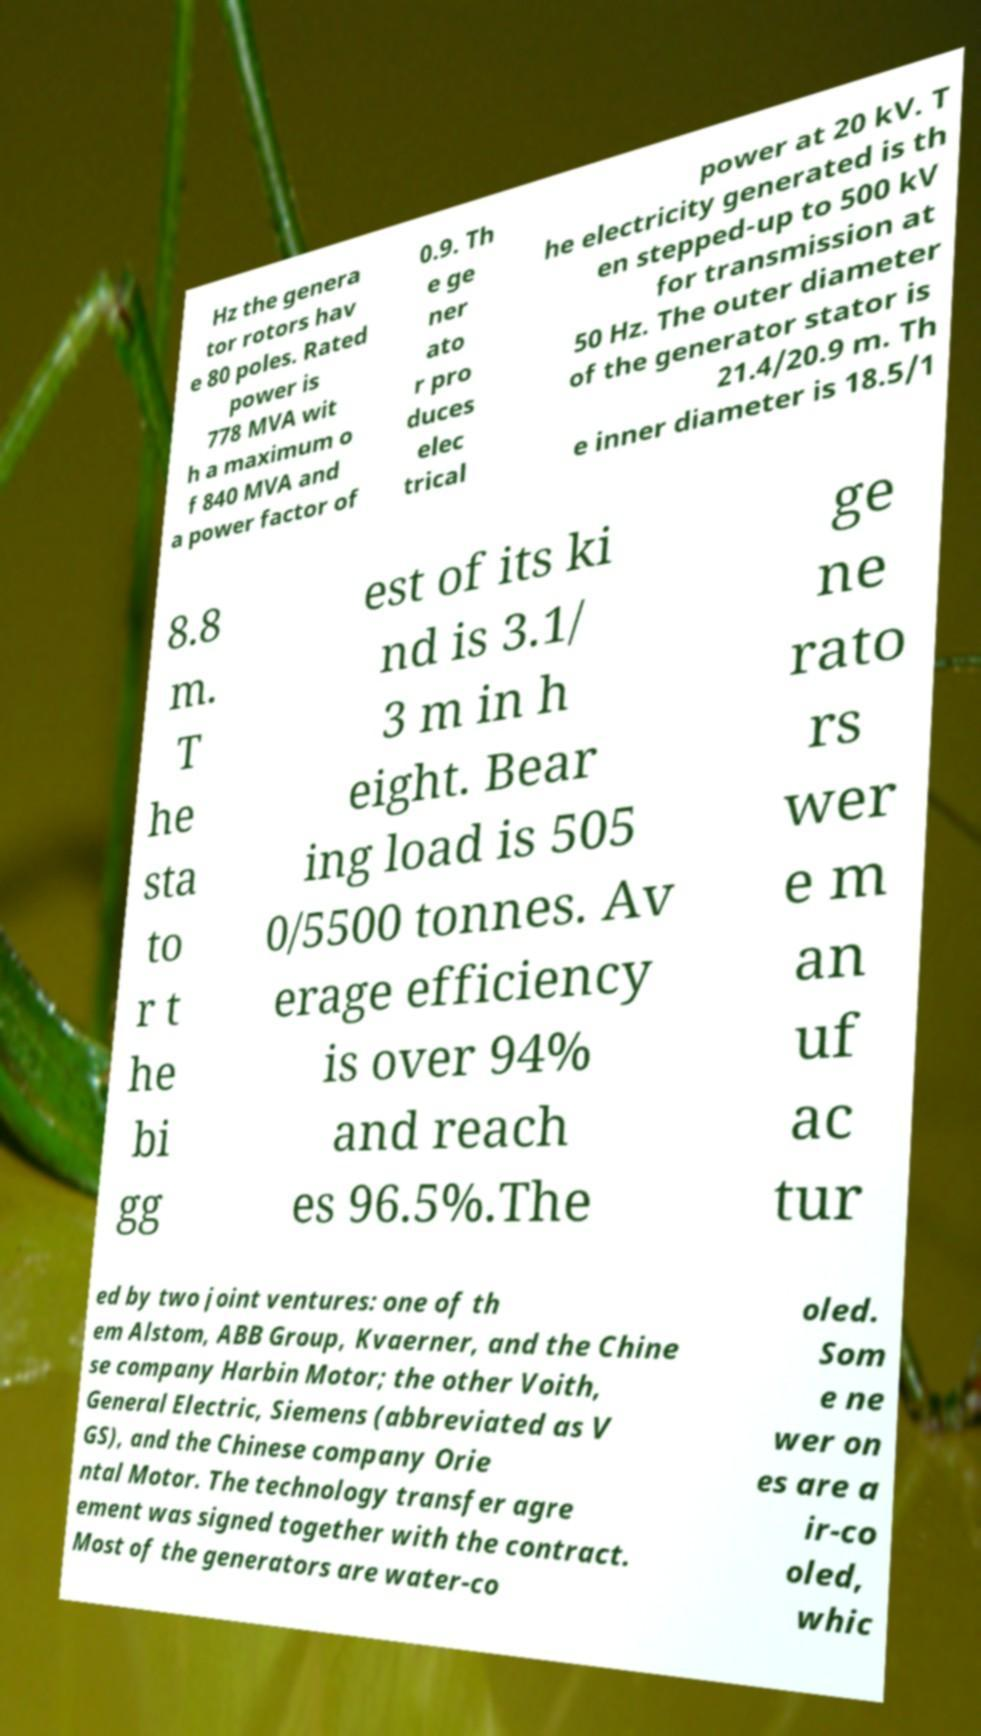Please identify and transcribe the text found in this image. Hz the genera tor rotors hav e 80 poles. Rated power is 778 MVA wit h a maximum o f 840 MVA and a power factor of 0.9. Th e ge ner ato r pro duces elec trical power at 20 kV. T he electricity generated is th en stepped-up to 500 kV for transmission at 50 Hz. The outer diameter of the generator stator is 21.4/20.9 m. Th e inner diameter is 18.5/1 8.8 m. T he sta to r t he bi gg est of its ki nd is 3.1/ 3 m in h eight. Bear ing load is 505 0/5500 tonnes. Av erage efficiency is over 94% and reach es 96.5%.The ge ne rato rs wer e m an uf ac tur ed by two joint ventures: one of th em Alstom, ABB Group, Kvaerner, and the Chine se company Harbin Motor; the other Voith, General Electric, Siemens (abbreviated as V GS), and the Chinese company Orie ntal Motor. The technology transfer agre ement was signed together with the contract. Most of the generators are water-co oled. Som e ne wer on es are a ir-co oled, whic 